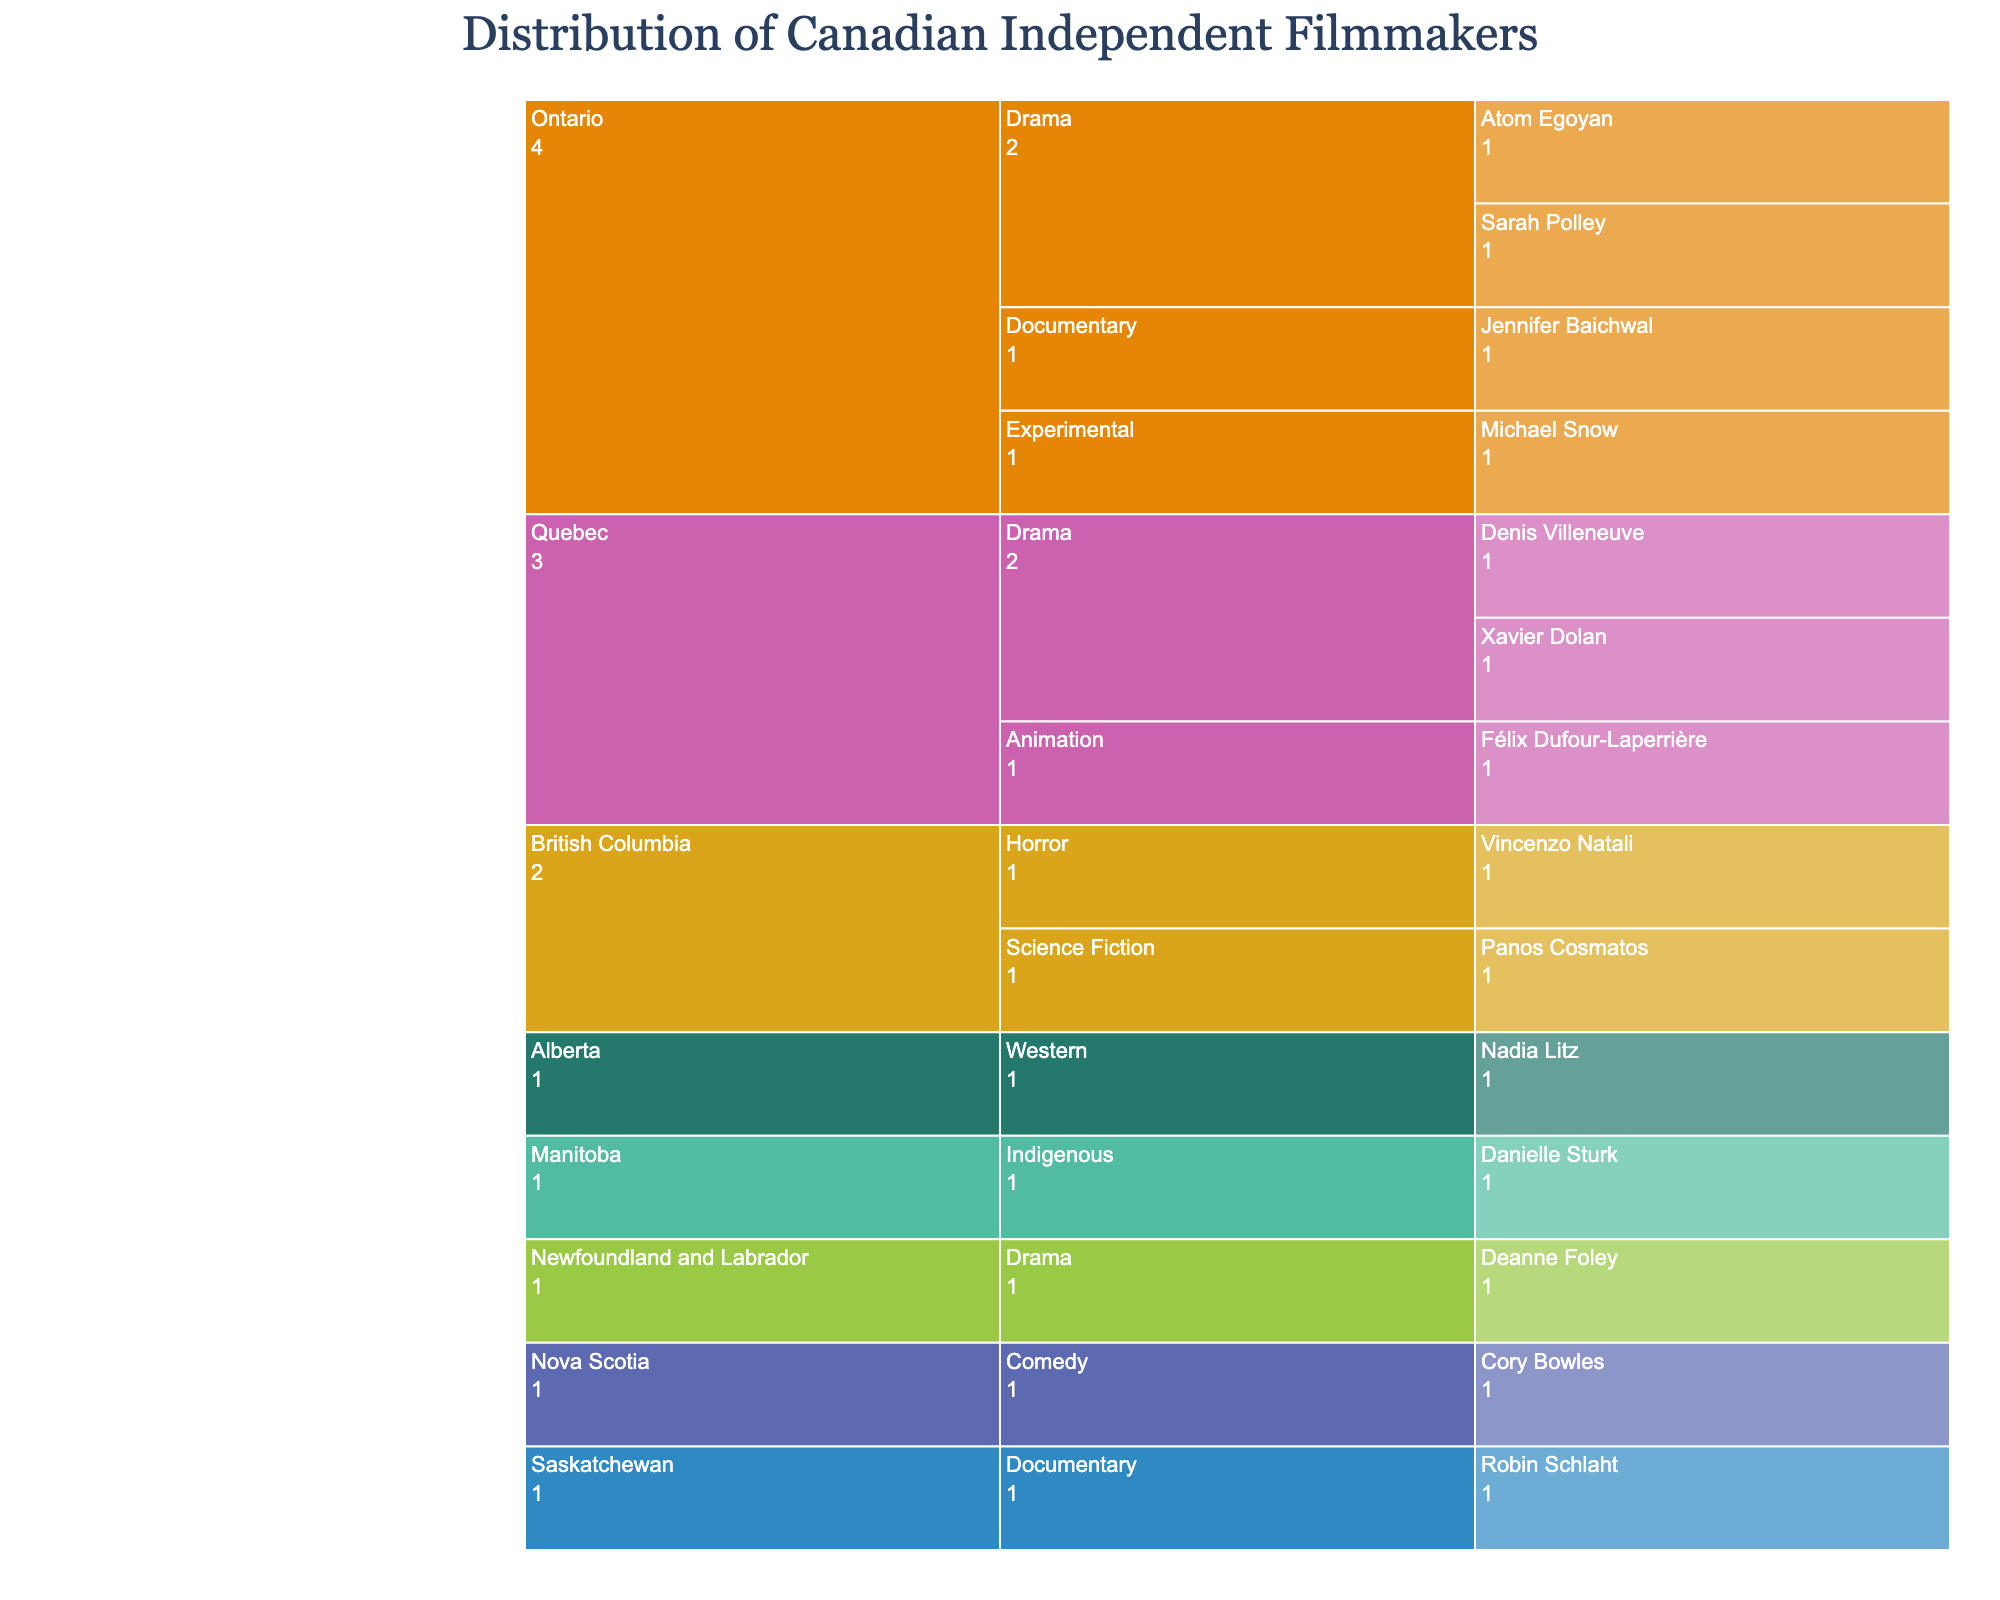What is the title of the Icicle Chart? The title is displayed at the top center of the chart.
Answer: Distribution of Canadian Independent Filmmakers Which province has the highest number of filmmakers shown in the chart? By examining the chart structure and the segments' sizes, Ontario has the largest branching, indicating the highest number of filmmakers.
Answer: Ontario How many genres are represented by filmmakers from Quebec? Look at the chart's branching under Quebec; it splits into three genres: Drama, Animation, and one other.
Answer: 3 Which filmmaker from Ontario is in the Experimental genre? Follow the Ontario branch, then the Experimental genre sub-branch, and identify the filmmaker listed under it.
Answer: Michael Snow How many total filmmakers are listed in the chart across all provinces? Sum up the individual filmmakers listed under each province. There are 14 filmmakers in total.
Answer: 14 Compare the number of Drama filmmakers between Ontario and Quebec. Which province has more Drama filmmakers? Ontario has two (Sarah Polley, Atom Egoyan) and Quebec has two (Denis Villeneuve, Xavier Dolan). The numbers are equal.
Answer: Equal How many provinces have an associated Drama genre? Identify all provinces with a sub-branch for Drama.
Answer: 3 Which genre is unique to Alberta according to the chart? Follow Alberta’s branch and check the genre listed. Alberta has only one genre represented.
Answer: Western Are there more filmmakers represented in Drama or Documentary genres? Count the filmmakers under Drama (4) and Documentary (2) by summing branches across all provinces.
Answer: Drama Which provinces have a single filmmaker listed? Check each province and see if only one filmmaker is under any given province. Alberta, Manitoba, Saskatchewan, and Newfoundland and Labrador have one filmmaker each.
Answer: Alberta, Manitoba, Saskatchewan, Newfoundland and Labrador 